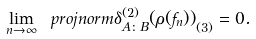Convert formula to latex. <formula><loc_0><loc_0><loc_500><loc_500>\lim _ { n \to \infty } \ p r o j n o r m { \delta _ { A \colon B } ^ { ( 2 ) } ( \rho ( f _ { n } ) ) } _ { ( 3 ) } = 0 .</formula> 